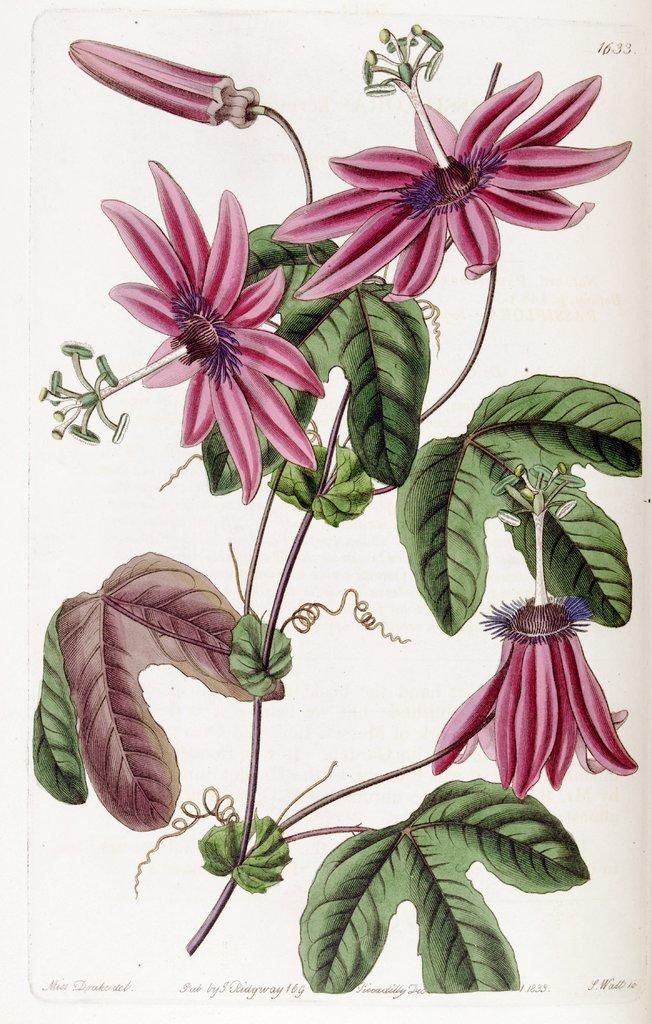What type of plant life can be seen in the image? There are flowers, leaves, branches, and buds visible in the image. Can you describe the stage of growth for the plants in the image? The presence of flowers, leaves, branches, and buds suggests that the plants are in various stages of growth. Is there any text or number visible in the image? Yes, there is a number visible in the top right side of the image. How does the process of digestion occur in the image? There is no reference to digestion or any living organisms in the image, so it is not possible to answer that question. 